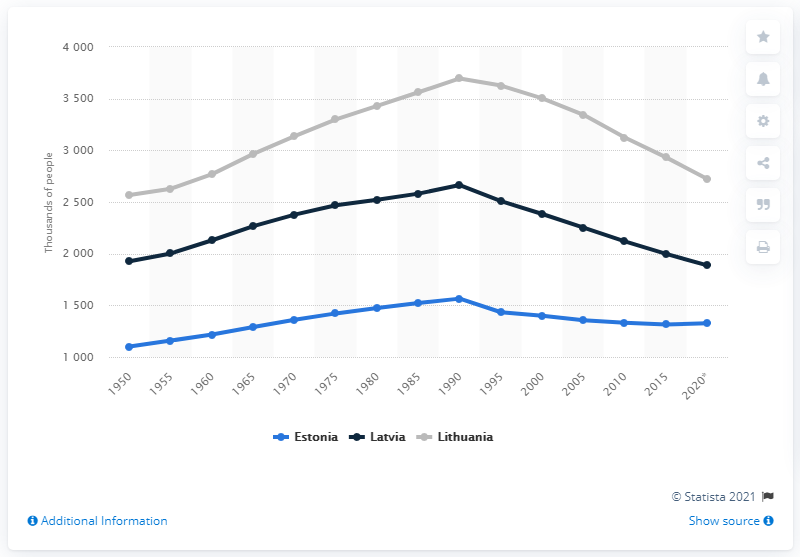Indicate a few pertinent items in this graphic. In the year 1950, the population of Estonia, Latvia, and Lithuania was approximately one, two, and 2.5 million people, respectively. 